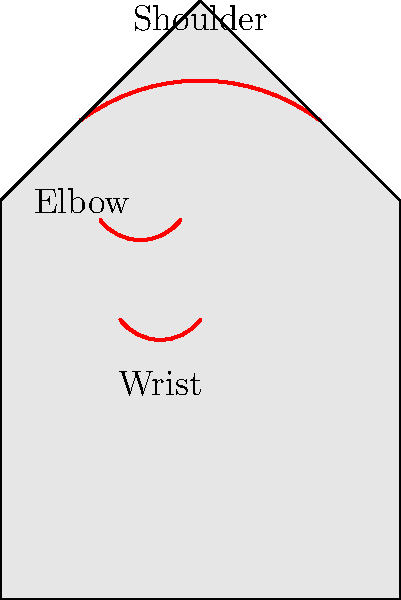In a factory where workers perform repetitive assembly line tasks, which of the following areas is most likely to develop repetitive stress injuries based on the anatomical drawing? How might this information influence the negotiation of labor contracts and workplace safety measures? To answer this question, we need to consider the nature of repetitive assembly line tasks and their impact on different body parts:

1. Shoulder: While involved in many movements, it's less likely to be the primary point of stress in most assembly line tasks.

2. Elbow: Often involved in repetitive motions, but generally more resilient than smaller joints.

3. Wrist: Most likely to be affected due to:
   a) Frequent small, precise movements in assembly tasks
   b) Limited range of motion compared to larger joints
   c) Complex structure with many small bones and tendons

4. Impact on labor contracts and workplace safety:
   a) Ergonomic considerations in workstation design
   b) Mandatory rest periods or job rotation to reduce continuous strain
   c) Implementation of worker training programs on proper techniques
   d) Regular health check-ups focusing on musculoskeletal issues
   e) Provisions for medical treatment and compensation for affected workers

5. Negotiation strategies:
   a) Use data on injury rates and associated costs to justify preventive measures
   b) Propose gradual implementation of ergonomic improvements
   c) Suggest pilot programs to test effectiveness of proposed changes
   d) Include clauses for regular review and update of safety measures

Understanding these factors allows for more informed negotiations, balancing worker safety with productivity concerns.
Answer: Wrist; influences ergonomic provisions, rest periods, health check-ups, and compensation in contracts. 